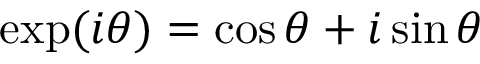<formula> <loc_0><loc_0><loc_500><loc_500>\exp ( i \theta ) = \cos \theta + i \sin \theta</formula> 